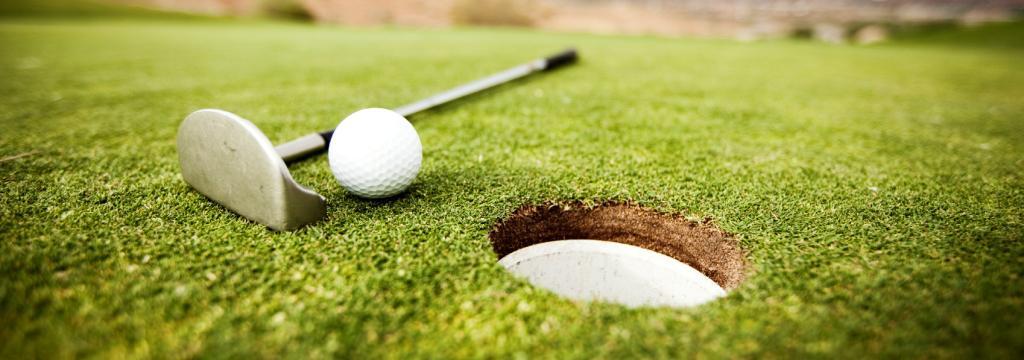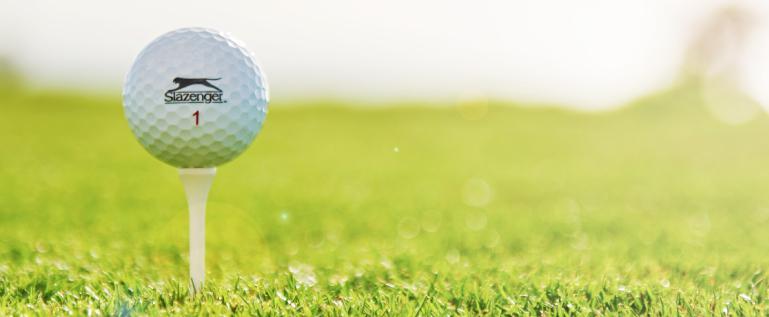The first image is the image on the left, the second image is the image on the right. Evaluate the accuracy of this statement regarding the images: "A golf ball is on a tee in one image.". Is it true? Answer yes or no. Yes. The first image is the image on the left, the second image is the image on the right. For the images displayed, is the sentence "At least one of the balls is sitting near the hole." factually correct? Answer yes or no. Yes. 